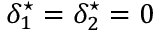Convert formula to latex. <formula><loc_0><loc_0><loc_500><loc_500>\delta _ { 1 } ^ { ^ { * } } = \delta _ { 2 } ^ { ^ { * } } = 0</formula> 